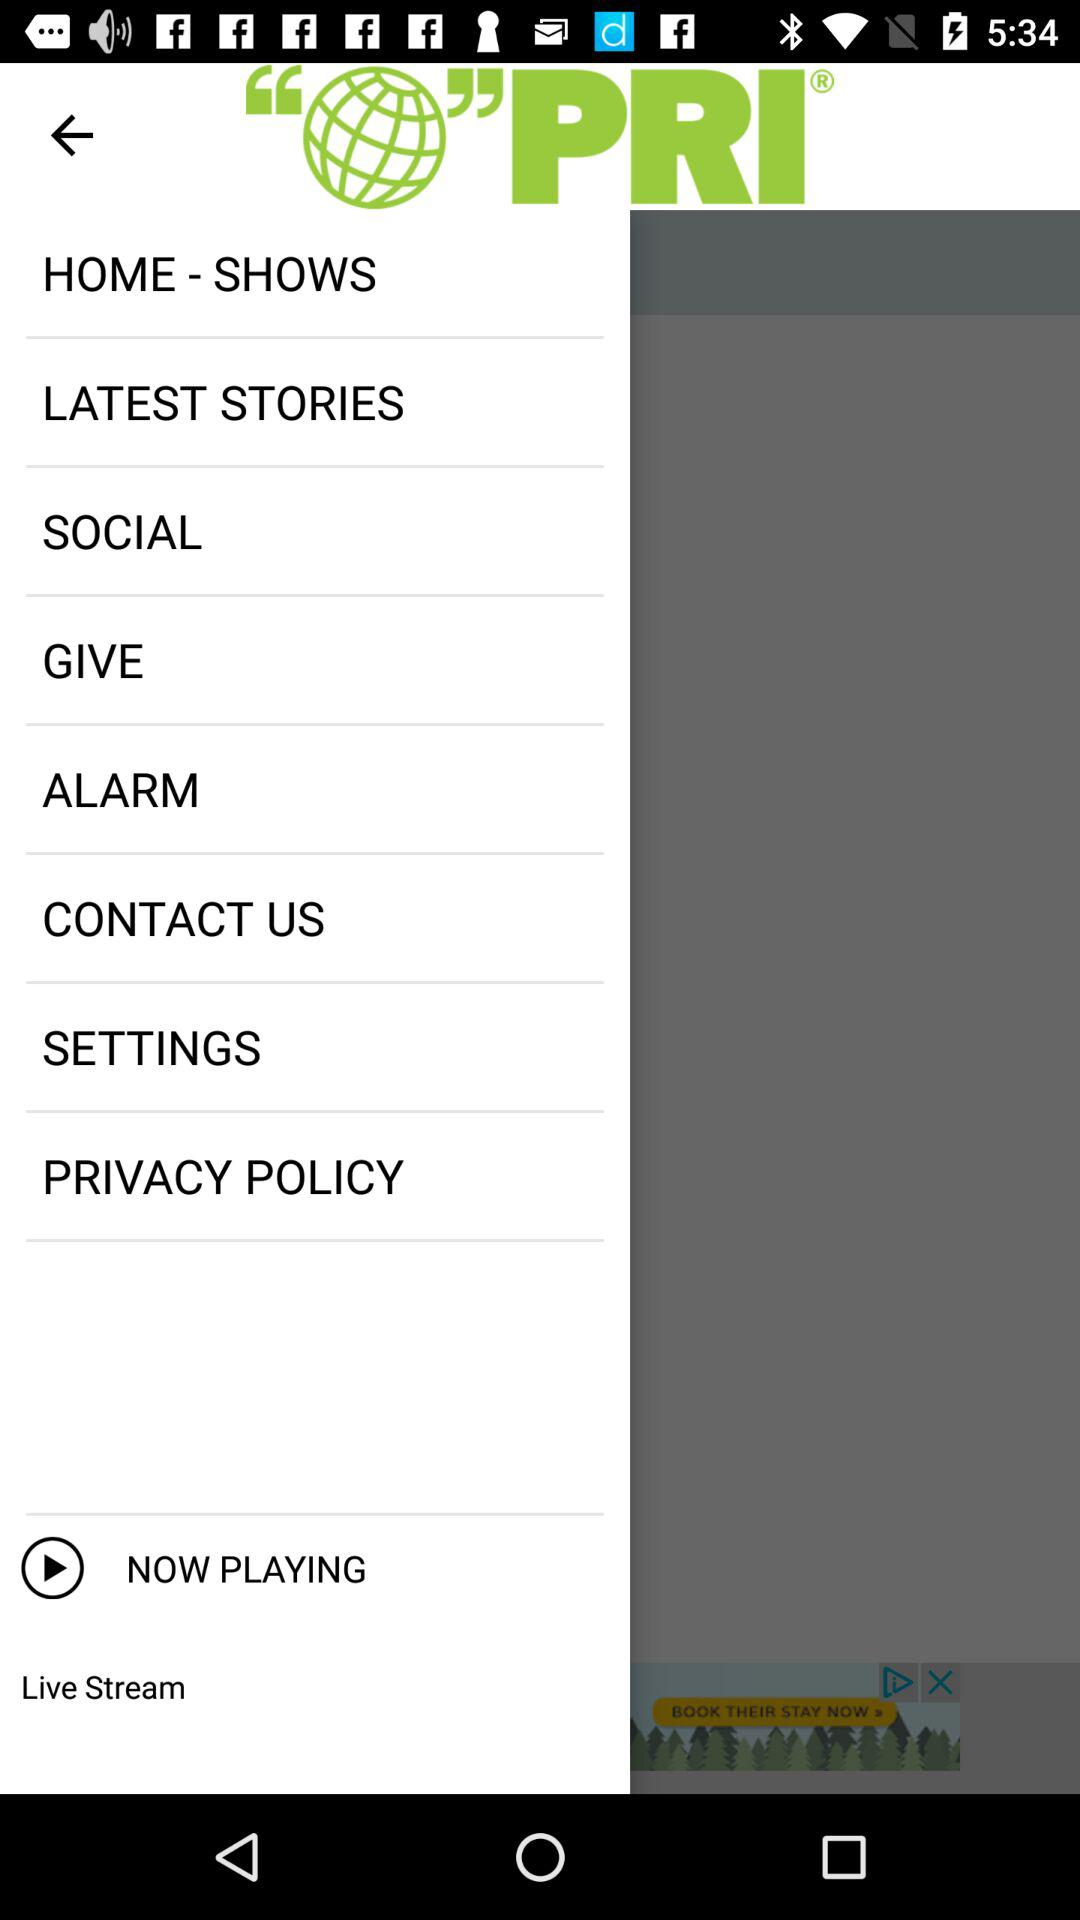What are the latest stories?
When the provided information is insufficient, respond with <no answer>. <no answer> 